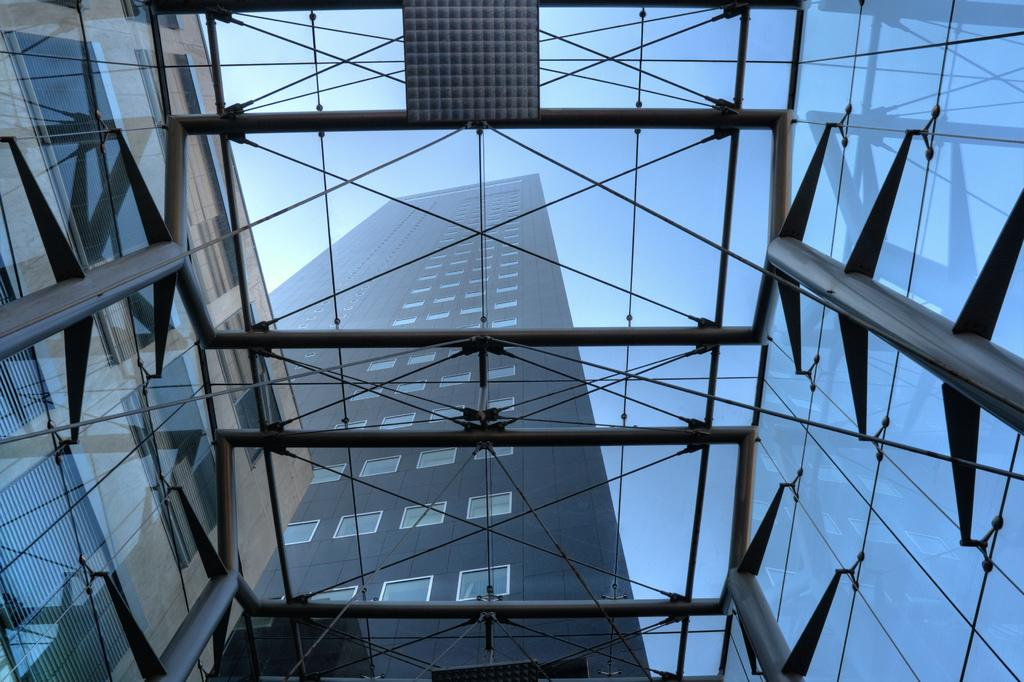What type of structures can be seen in the image? There are buildings in the image. What is visible at the top of the image? The sky is visible at the top of the image. How many beans are present in the image? There are no beans visible in the image. What type of hands can be seen interacting with the buildings in the image? There are no hands present in the image; it only shows buildings and the sky. 